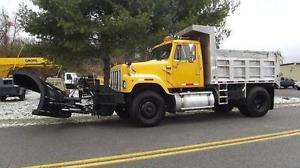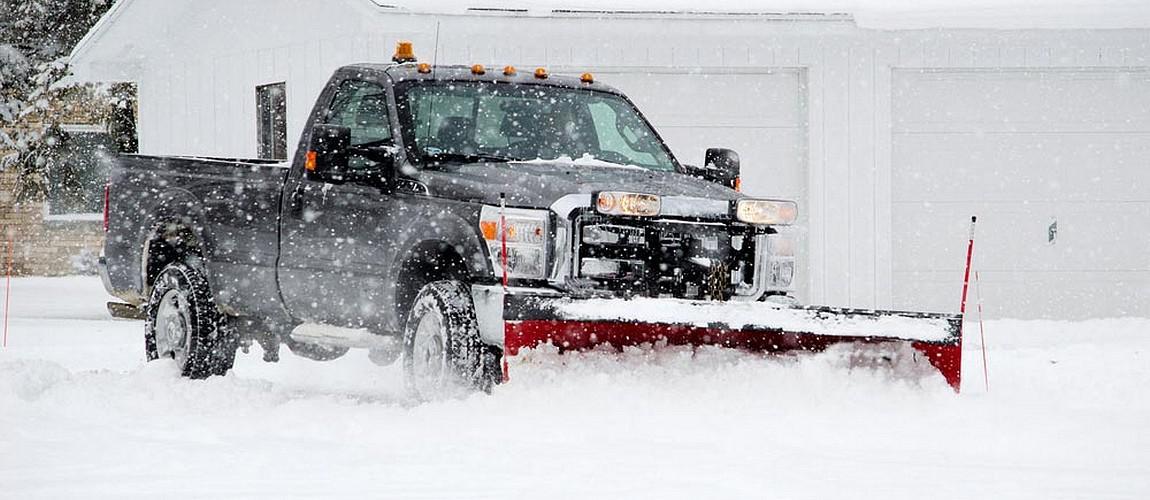The first image is the image on the left, the second image is the image on the right. Examine the images to the left and right. Is the description "In one of the images, the snow plow is not pushing snow." accurate? Answer yes or no. Yes. 